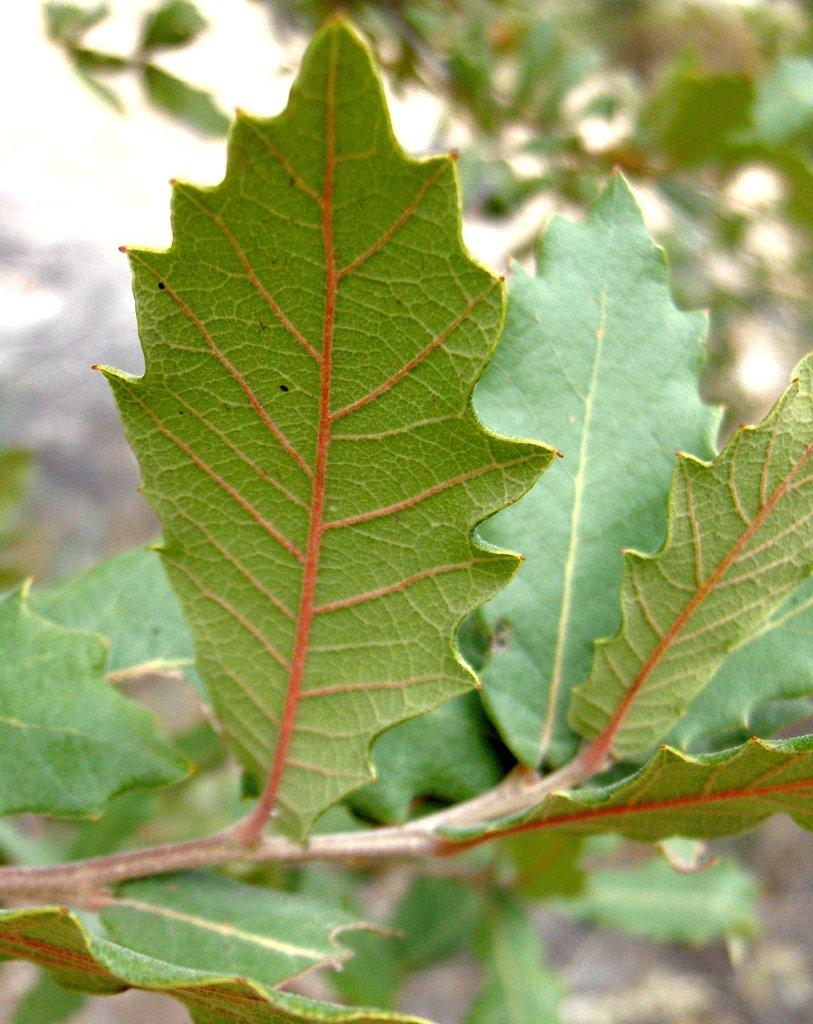Where was the image taken? The image was taken outdoors. What can be seen in the image besides the outdoor setting? There is a tree in the image. What is the condition of the tree's leaves? The tree has green leaves. What type of education can be seen taking place in the image? There is no indication of any educational activity in the image; it features a tree with green leaves in an outdoor setting. 